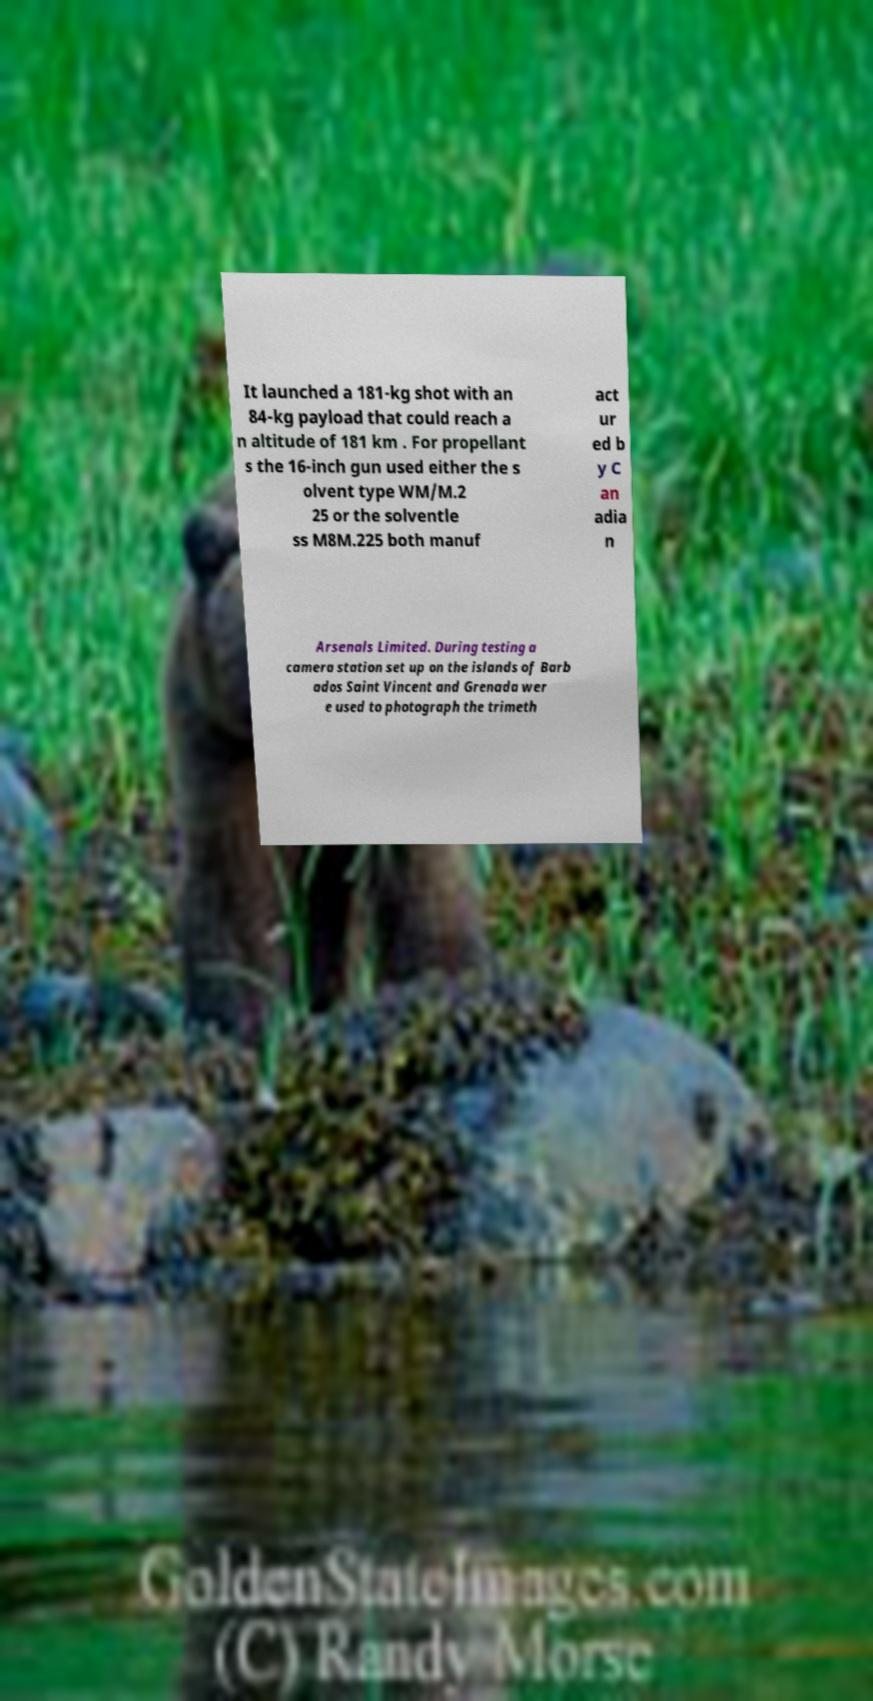Could you assist in decoding the text presented in this image and type it out clearly? It launched a 181-kg shot with an 84-kg payload that could reach a n altitude of 181 km . For propellant s the 16-inch gun used either the s olvent type WM/M.2 25 or the solventle ss M8M.225 both manuf act ur ed b y C an adia n Arsenals Limited. During testing a camera station set up on the islands of Barb ados Saint Vincent and Grenada wer e used to photograph the trimeth 